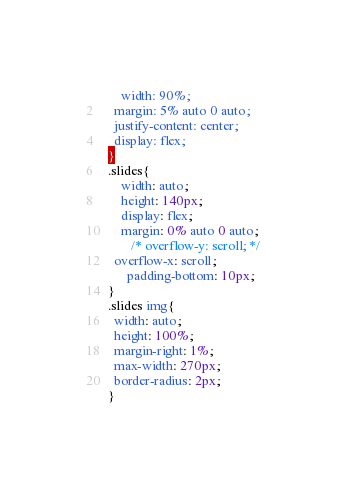<code> <loc_0><loc_0><loc_500><loc_500><_CSS_>      width: 90%;
    margin: 5% auto 0 auto;
    justify-content: center;
    display: flex;
  }
  .slides{
      width: auto;
      height: 140px;
      display: flex;
      margin: 0% auto 0 auto;
         /* overflow-y: scroll; */
    overflow-x: scroll;
        padding-bottom: 10px;
  }
  .slides img{
    width: auto;
    height: 100%;
    margin-right: 1%;
    max-width: 270px;
    border-radius: 2px;
  }</code> 